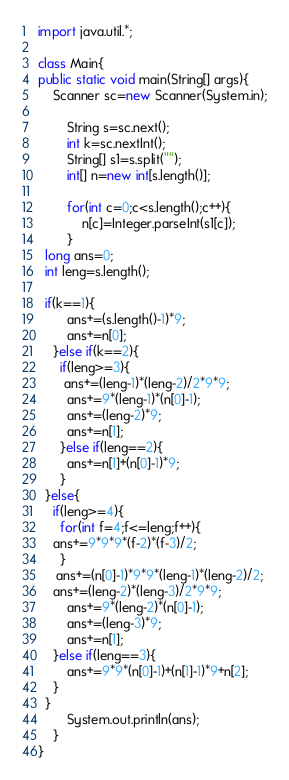<code> <loc_0><loc_0><loc_500><loc_500><_Java_>import java.util.*; 

class Main{
public static void main(String[] args){
	Scanner sc=new Scanner(System.in);
        
        String s=sc.next();
		int k=sc.nextInt();
  		String[] s1=s.split("");
  		int[] n=new int[s.length()];
  
		for(int c=0;c<s.length();c++){
    		n[c]=Integer.parseInt(s1[c]);
    	}
  long ans=0;
  int leng=s.length();
    
  if(k==1){
    	ans+=(s.length()-1)*9;
      	ans+=n[0];
    }else if(k==2){
      if(leng>=3){
       ans+=(leng-1)*(leng-2)/2*9*9;
        ans+=9*(leng-1)*(n[0]-1);
        ans+=(leng-2)*9;
		ans+=n[1];
      }else if(leng==2){
      	ans+=n[1]+(n[0]-1)*9;
      }
  }else{
    if(leng>=4){
      for(int f=4;f<=leng;f++){
    ans+=9*9*9*(f-2)*(f-3)/2;
      }
     ans+=(n[0]-1)*9*9*(leng-1)*(leng-2)/2;
  	ans+=(leng-2)*(leng-3)/2*9*9;
        ans+=9*(leng-2)*(n[0]-1);
        ans+=(leng-3)*9;
		ans+=n[1];
    }else if(leng==3){
    	ans+=9*9*(n[0]-1)+(n[1]-1)*9+n[2];
    }
  }
    	System.out.println(ans);
    }
}</code> 